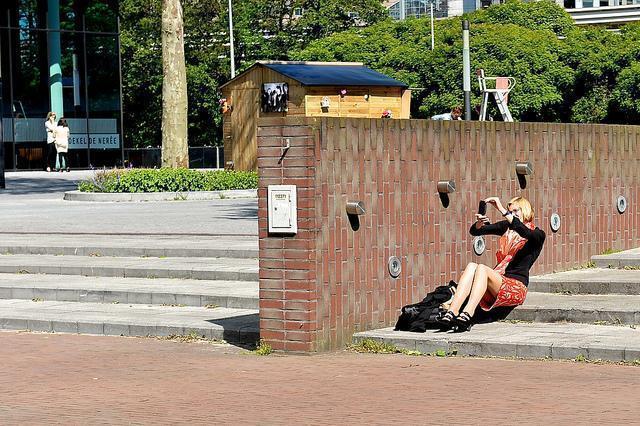Why does the woman have her arms out?
Choose the correct response, then elucidate: 'Answer: answer
Rationale: rationale.'
Options: Measure, take picture, wave, balance. Answer: take picture.
Rationale: The woman is trying to take a photo. 